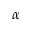<formula> <loc_0><loc_0><loc_500><loc_500>\alpha</formula> 